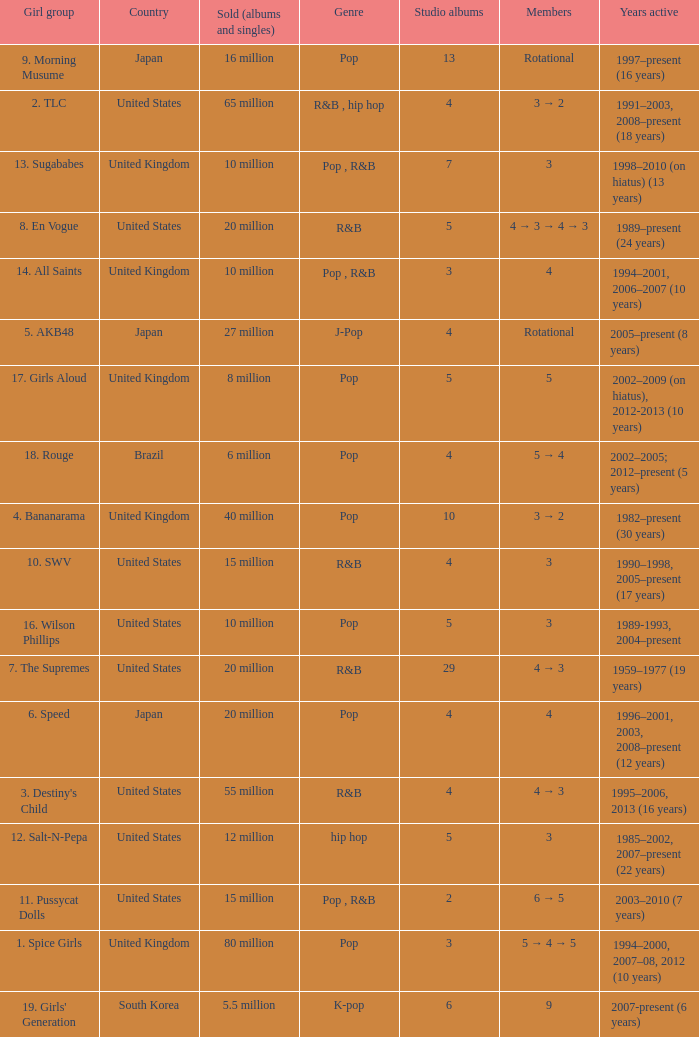How many members were in the group that sold 65 million albums and singles? 3 → 2. 